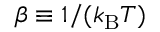Convert formula to latex. <formula><loc_0><loc_0><loc_500><loc_500>\beta \equiv 1 / ( k _ { B } T )</formula> 